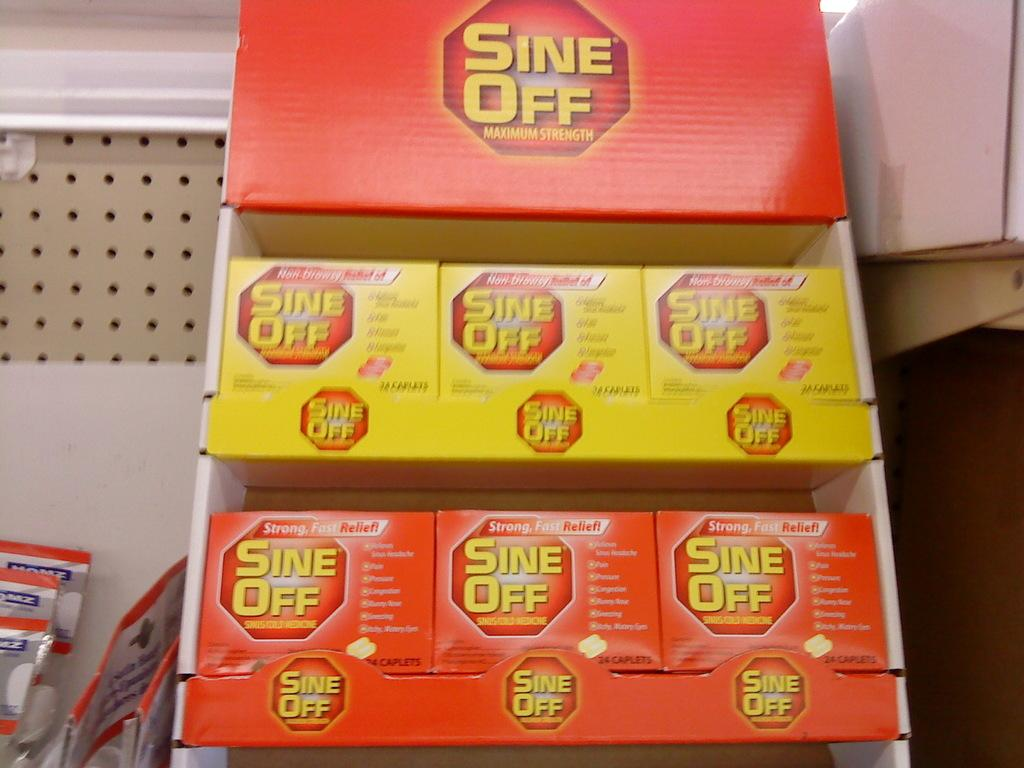<image>
Give a short and clear explanation of the subsequent image. Several boxes of Sine Off sit in a cardboard display box. 